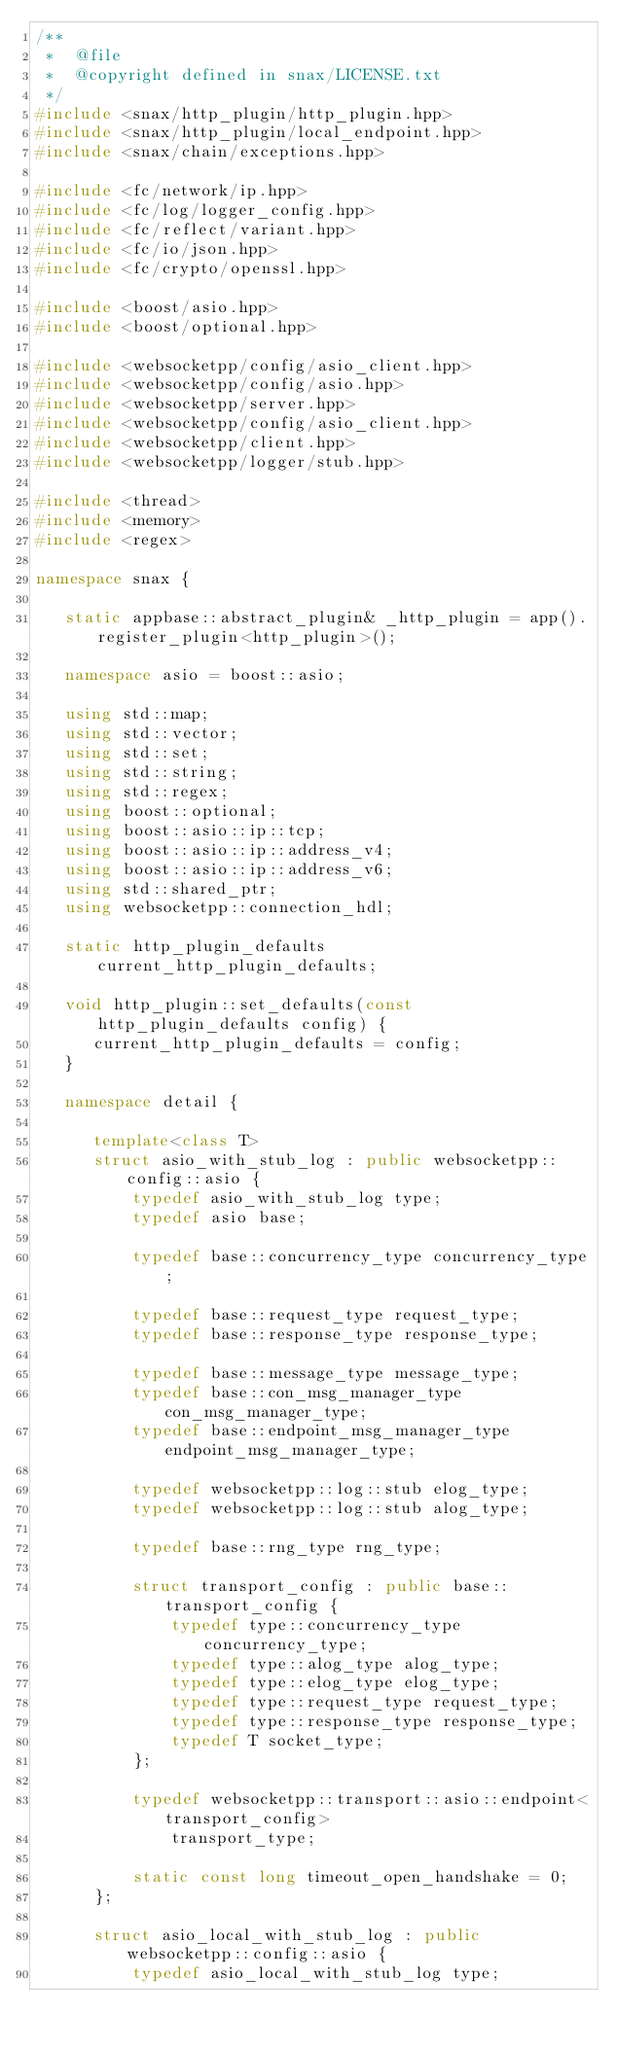Convert code to text. <code><loc_0><loc_0><loc_500><loc_500><_C++_>/**
 *  @file
 *  @copyright defined in snax/LICENSE.txt
 */
#include <snax/http_plugin/http_plugin.hpp>
#include <snax/http_plugin/local_endpoint.hpp>
#include <snax/chain/exceptions.hpp>

#include <fc/network/ip.hpp>
#include <fc/log/logger_config.hpp>
#include <fc/reflect/variant.hpp>
#include <fc/io/json.hpp>
#include <fc/crypto/openssl.hpp>

#include <boost/asio.hpp>
#include <boost/optional.hpp>

#include <websocketpp/config/asio_client.hpp>
#include <websocketpp/config/asio.hpp>
#include <websocketpp/server.hpp>
#include <websocketpp/config/asio_client.hpp>
#include <websocketpp/client.hpp>
#include <websocketpp/logger/stub.hpp>

#include <thread>
#include <memory>
#include <regex>

namespace snax {

   static appbase::abstract_plugin& _http_plugin = app().register_plugin<http_plugin>();

   namespace asio = boost::asio;

   using std::map;
   using std::vector;
   using std::set;
   using std::string;
   using std::regex;
   using boost::optional;
   using boost::asio::ip::tcp;
   using boost::asio::ip::address_v4;
   using boost::asio::ip::address_v6;
   using std::shared_ptr;
   using websocketpp::connection_hdl;

   static http_plugin_defaults current_http_plugin_defaults;

   void http_plugin::set_defaults(const http_plugin_defaults config) {
      current_http_plugin_defaults = config;
   }

   namespace detail {

      template<class T>
      struct asio_with_stub_log : public websocketpp::config::asio {
          typedef asio_with_stub_log type;
          typedef asio base;

          typedef base::concurrency_type concurrency_type;

          typedef base::request_type request_type;
          typedef base::response_type response_type;

          typedef base::message_type message_type;
          typedef base::con_msg_manager_type con_msg_manager_type;
          typedef base::endpoint_msg_manager_type endpoint_msg_manager_type;

          typedef websocketpp::log::stub elog_type;
          typedef websocketpp::log::stub alog_type;

          typedef base::rng_type rng_type;

          struct transport_config : public base::transport_config {
              typedef type::concurrency_type concurrency_type;
              typedef type::alog_type alog_type;
              typedef type::elog_type elog_type;
              typedef type::request_type request_type;
              typedef type::response_type response_type;
              typedef T socket_type;
          };

          typedef websocketpp::transport::asio::endpoint<transport_config>
              transport_type;

          static const long timeout_open_handshake = 0;
      };

      struct asio_local_with_stub_log : public websocketpp::config::asio {
          typedef asio_local_with_stub_log type;</code> 